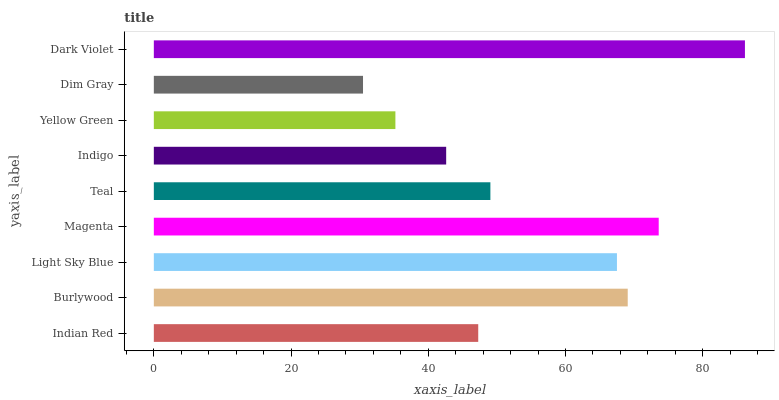Is Dim Gray the minimum?
Answer yes or no. Yes. Is Dark Violet the maximum?
Answer yes or no. Yes. Is Burlywood the minimum?
Answer yes or no. No. Is Burlywood the maximum?
Answer yes or no. No. Is Burlywood greater than Indian Red?
Answer yes or no. Yes. Is Indian Red less than Burlywood?
Answer yes or no. Yes. Is Indian Red greater than Burlywood?
Answer yes or no. No. Is Burlywood less than Indian Red?
Answer yes or no. No. Is Teal the high median?
Answer yes or no. Yes. Is Teal the low median?
Answer yes or no. Yes. Is Burlywood the high median?
Answer yes or no. No. Is Yellow Green the low median?
Answer yes or no. No. 